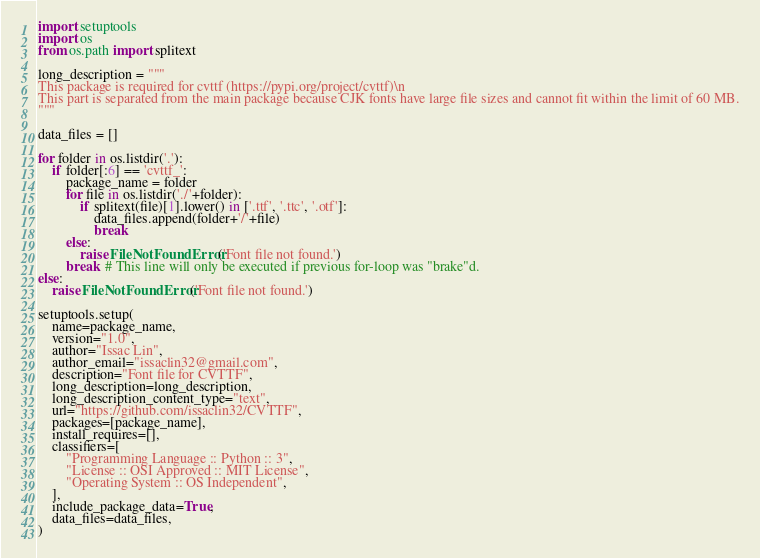Convert code to text. <code><loc_0><loc_0><loc_500><loc_500><_Python_>import setuptools
import os
from os.path import splitext

long_description = """
This package is required for cvttf (https://pypi.org/project/cvttf)\n
This part is separated from the main package because CJK fonts have large file sizes and cannot fit within the limit of 60 MB.
"""

data_files = []

for folder in os.listdir('.'):
    if folder[:6] == 'cvttf_':
        package_name = folder
        for file in os.listdir('./'+folder):
            if splitext(file)[1].lower() in ['.ttf', '.ttc', '.otf']:
                data_files.append(folder+'/'+file)
                break
        else:
            raise FileNotFoundError('Font file not found.')
        break  # This line will only be executed if previous for-loop was "brake"d.
else:
    raise FileNotFoundError('Font file not found.')

setuptools.setup(
    name=package_name,
    version="1.0",
    author="Issac Lin",
    author_email="issaclin32@gmail.com",
    description="Font file for CVTTF",
    long_description=long_description,
    long_description_content_type="text",
    url="https://github.com/issaclin32/CVTTF",
    packages=[package_name],
    install_requires=[],
    classifiers=[
        "Programming Language :: Python :: 3",
        "License :: OSI Approved :: MIT License",
        "Operating System :: OS Independent",
    ],
    include_package_data=True,
    data_files=data_files,
)</code> 